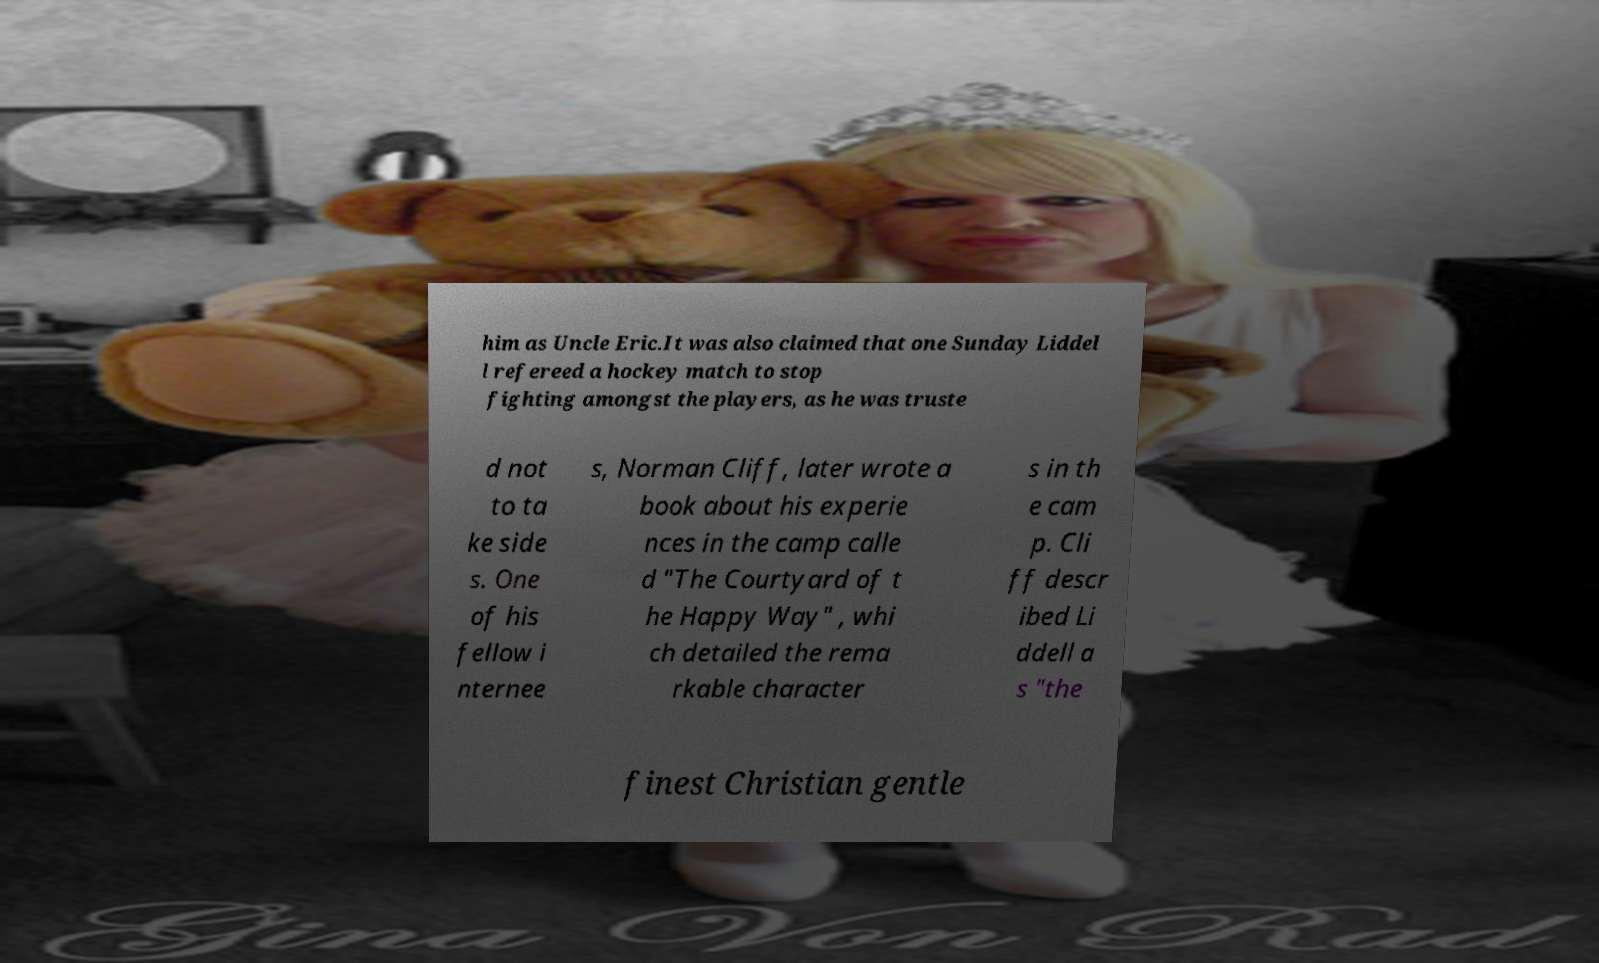What messages or text are displayed in this image? I need them in a readable, typed format. him as Uncle Eric.It was also claimed that one Sunday Liddel l refereed a hockey match to stop fighting amongst the players, as he was truste d not to ta ke side s. One of his fellow i nternee s, Norman Cliff, later wrote a book about his experie nces in the camp calle d "The Courtyard of t he Happy Way" , whi ch detailed the rema rkable character s in th e cam p. Cli ff descr ibed Li ddell a s "the finest Christian gentle 